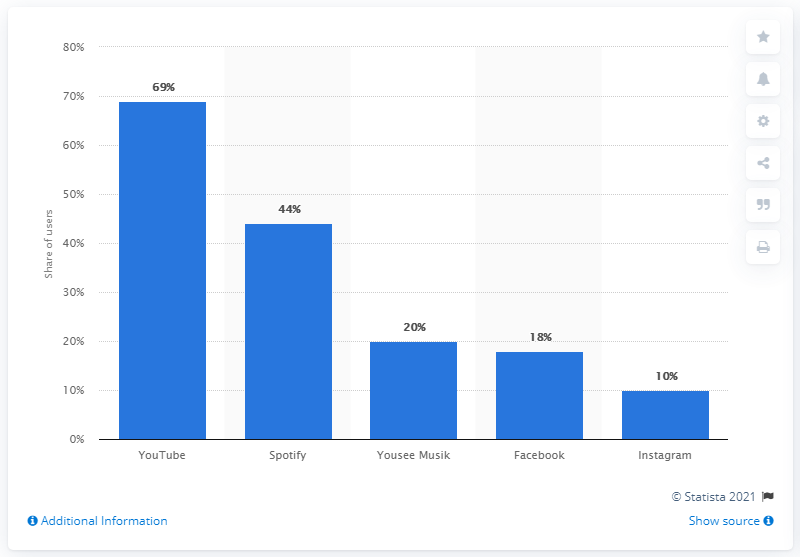Can you tell me how Facebook and Instagram rank in terms of music service usage in Denmark? Certainly, according to the bar chart presented, Facebook has a usage share of 1.8% and Instagram has an even lower share at 1%, ranking them significantly lower than the dedicated music services in terms of usage for music in Denmark. 